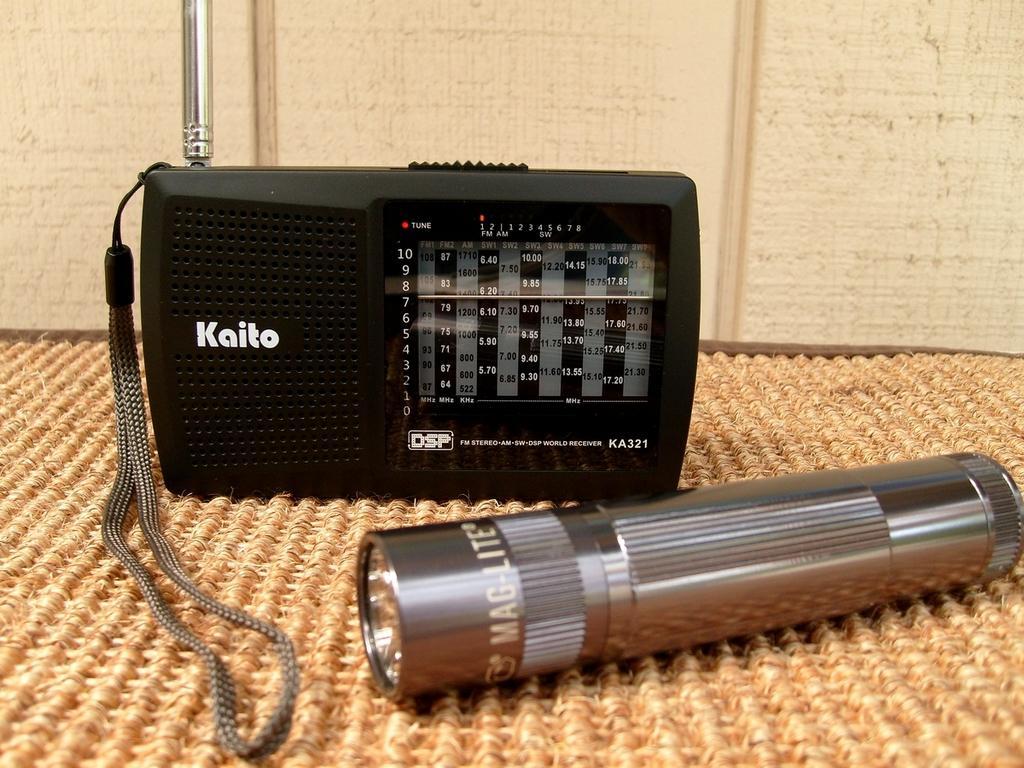In one or two sentences, can you explain what this image depicts? In this image, we can see a radio and a torch on the mat and in the background, there is a board. 